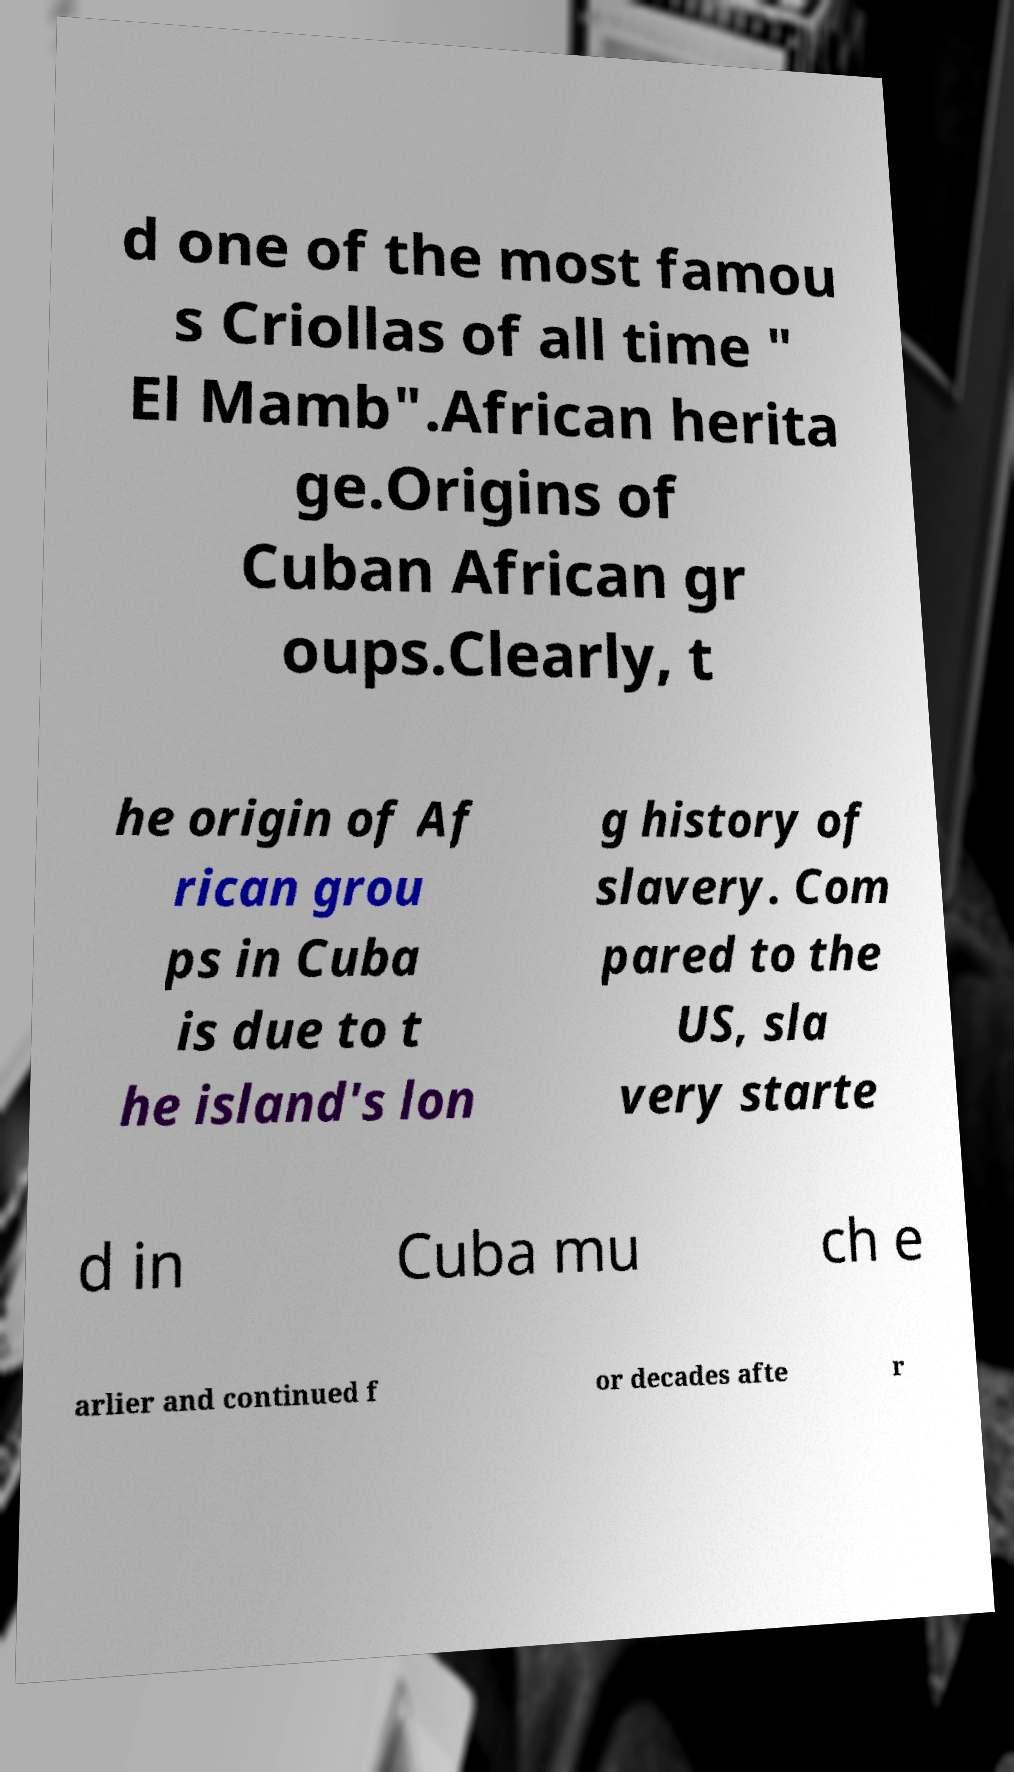Could you extract and type out the text from this image? d one of the most famou s Criollas of all time " El Mamb".African herita ge.Origins of Cuban African gr oups.Clearly, t he origin of Af rican grou ps in Cuba is due to t he island's lon g history of slavery. Com pared to the US, sla very starte d in Cuba mu ch e arlier and continued f or decades afte r 